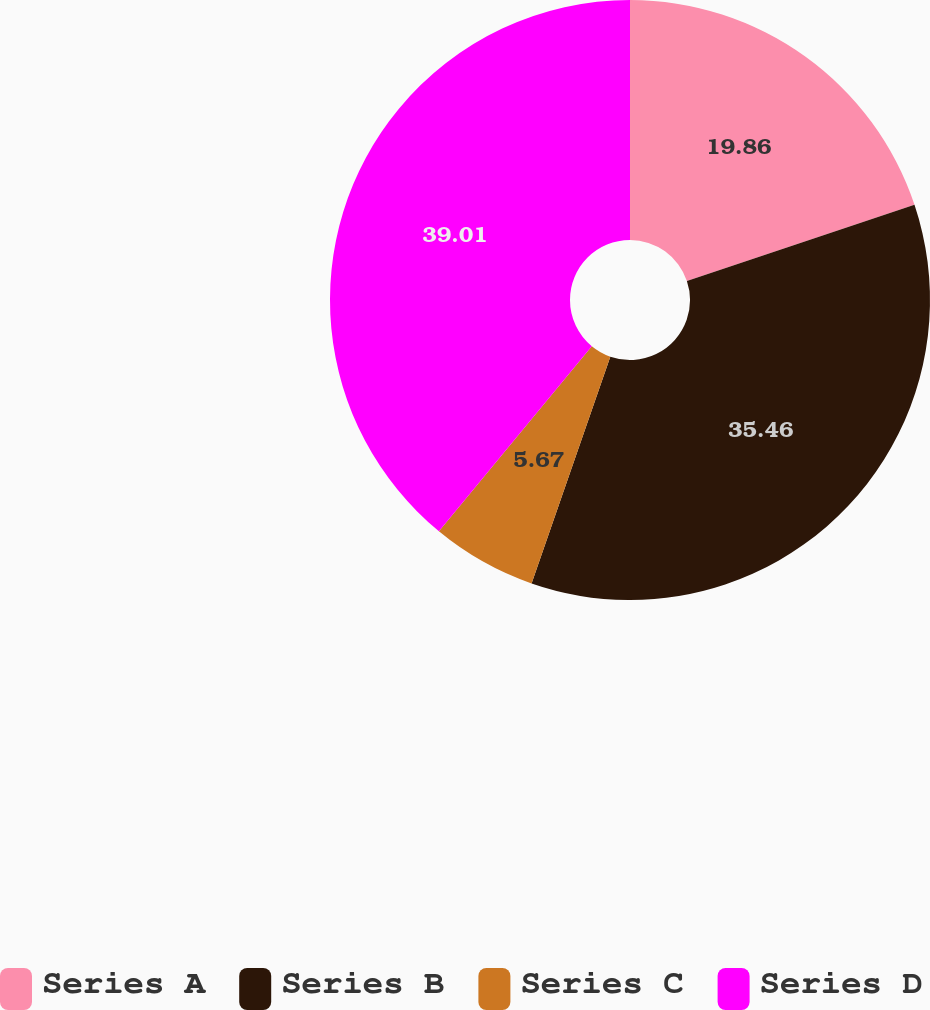Convert chart to OTSL. <chart><loc_0><loc_0><loc_500><loc_500><pie_chart><fcel>Series A<fcel>Series B<fcel>Series C<fcel>Series D<nl><fcel>19.86%<fcel>35.46%<fcel>5.67%<fcel>39.01%<nl></chart> 